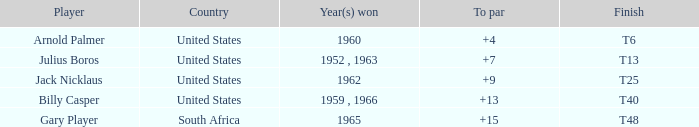Which player from the United States won in 1962? Jack Nicklaus. 